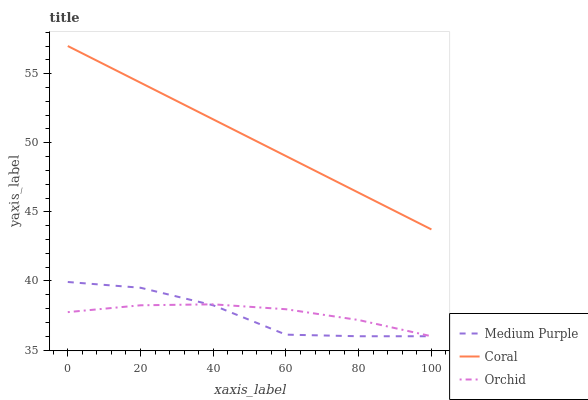Does Orchid have the minimum area under the curve?
Answer yes or no. No. Does Orchid have the maximum area under the curve?
Answer yes or no. No. Is Orchid the smoothest?
Answer yes or no. No. Is Orchid the roughest?
Answer yes or no. No. Does Coral have the lowest value?
Answer yes or no. No. Does Orchid have the highest value?
Answer yes or no. No. Is Orchid less than Coral?
Answer yes or no. Yes. Is Coral greater than Medium Purple?
Answer yes or no. Yes. Does Orchid intersect Coral?
Answer yes or no. No. 